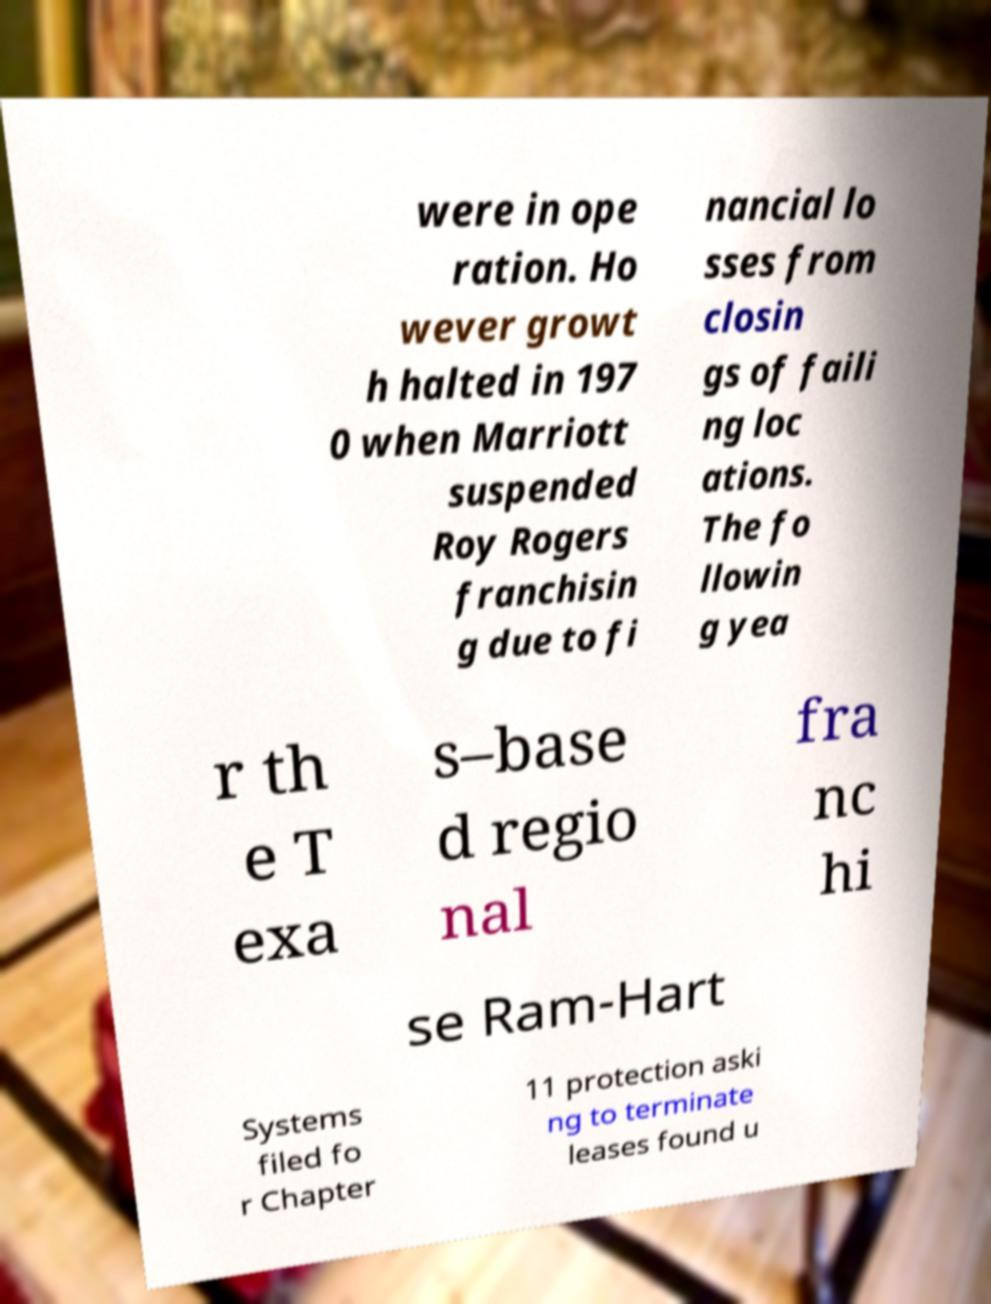I need the written content from this picture converted into text. Can you do that? were in ope ration. Ho wever growt h halted in 197 0 when Marriott suspended Roy Rogers franchisin g due to fi nancial lo sses from closin gs of faili ng loc ations. The fo llowin g yea r th e T exa s–base d regio nal fra nc hi se Ram-Hart Systems filed fo r Chapter 11 protection aski ng to terminate leases found u 